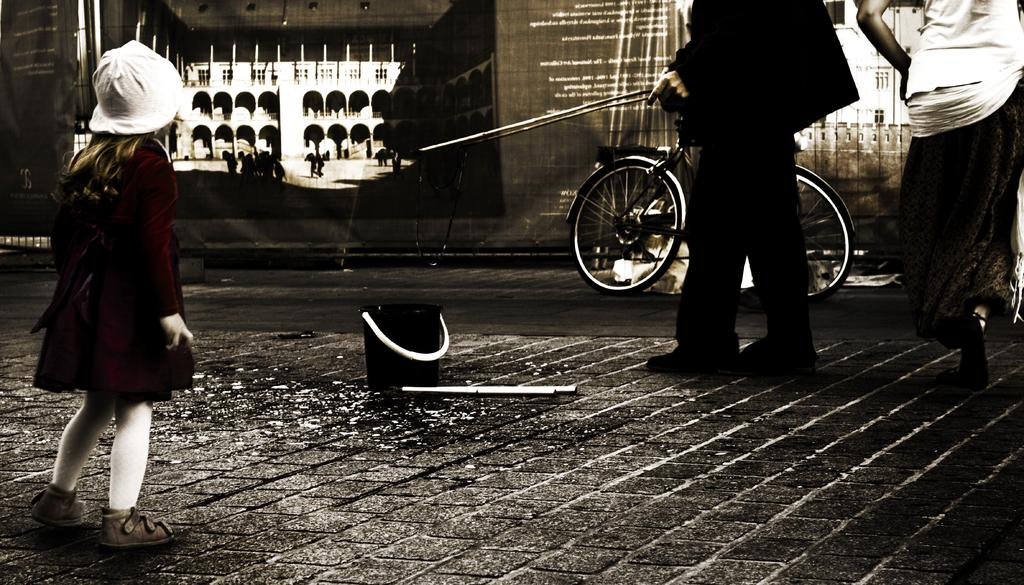What are the persons in the image wearing? The persons in the image are wearing clothes. What can be seen beside a banner in the image? There is a cycle beside a banner in the image. What is located in the middle of the image? There is a bucket and a stick in the middle of the image. What type of milk can be seen being poured from the bucket in the image? There is no milk present in the image; it features a bucket and a stick in the middle. How many roses are visible on the persons in the image? There is no rose present in the image; the persons are wearing clothes, but no specific details about the clothes are provided. 